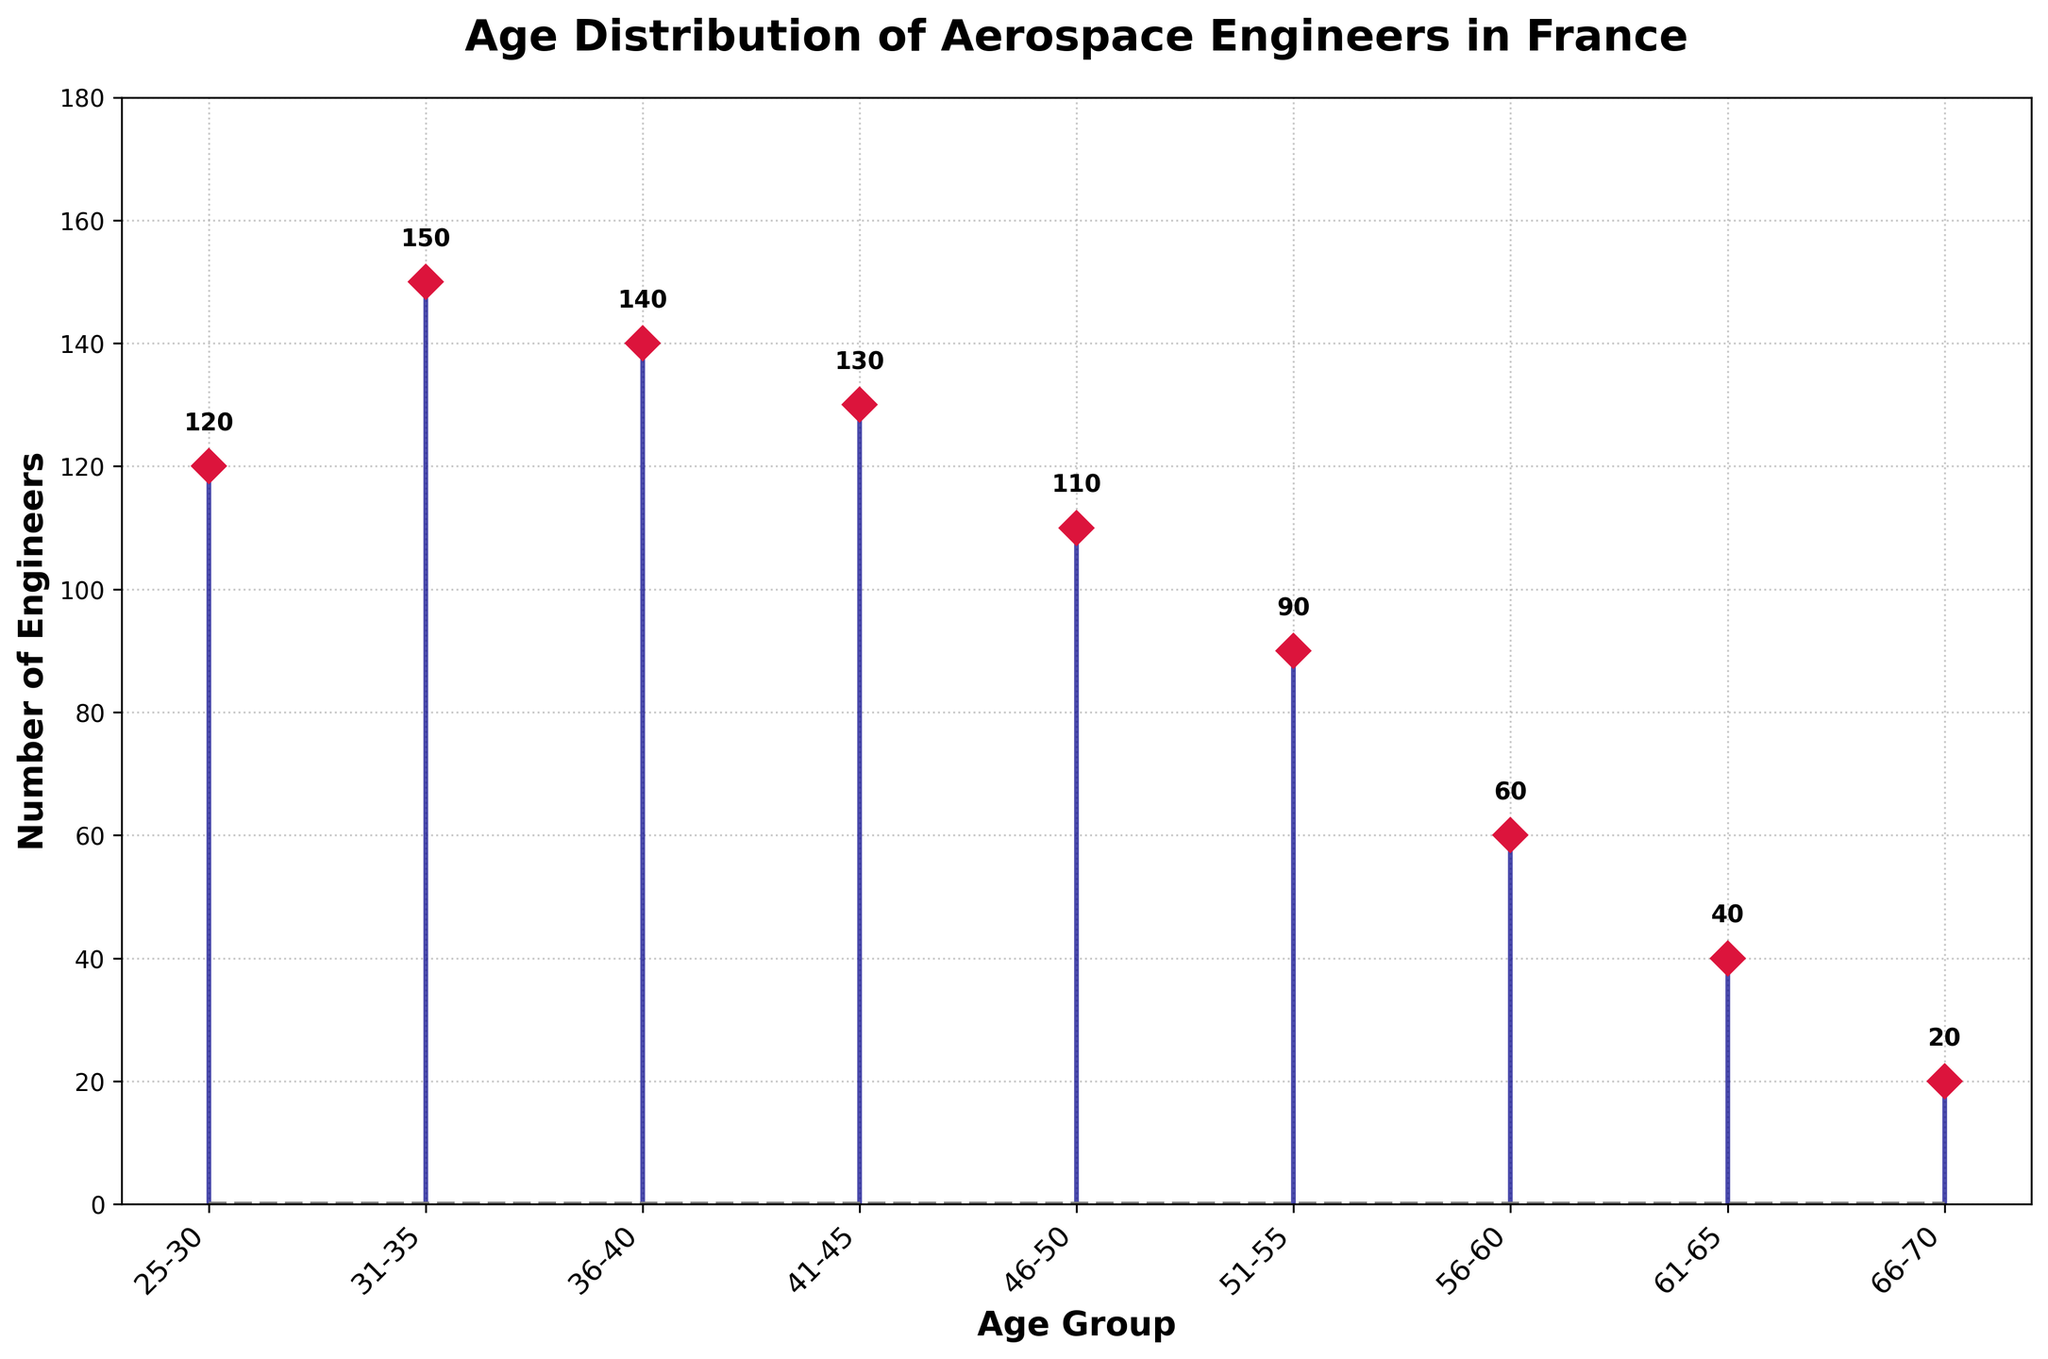What is the age distribution of aerospace engineers in France? The stem plot shows the age groups along the x-axis, ranging from 25-30 to 66-70, with the number of engineers represented by stems on the y-axis. The total number of age groups indicated is 9.
Answer: 9 age groups What is the highest number of engineers in any age group, and which group does it belong to? The tallest stem in the plot represents the highest number, which corresponds to the age group labeled 31-35. The number above this stem is 150.
Answer: 150, 31-35 Which age group has the lowest number of engineers, and how many engineers are in that group? The shortest stem in the plot corresponds to the age group labeled 66-70. The number above this stem is 20.
Answer: 20, 66-70 Compare the number of engineers in the age groups 36-40 and 41-45. Which age group has more engineers? The stems for the age groups 36-40 and 41-45 can be compared by their height and the numbers on top. The number for 36-40 is 140, and for 41-45, it is 130.
Answer: 36-40 What is the total number of aerospace engineers represented in the figure for all age groups? Sum the values of all the stems: 120 + 150 + 140 + 130 + 110 + 90 + 60 + 40 + 20 = 860.
Answer: 860 What is the average number of engineers per age group? Divide the total number of engineers by the number of age groups: 860 / 9 ≈ 95.56.
Answer: 95.56 Which age groups have at least 100 aerospace engineers? Identify the age groups by comparing the heights of the stems to find those with numbers above 100: 25-30 (120), 31-35 (150), 36-40 (140), 41-45 (130), 46-50 (110).
Answer: 25-30, 31-35, 36-40, 41-45, 46-50 What is the difference in the number of engineers between the age groups 51-55 and 56-60? Subtract the number of engineers in 56-60 from 51-55: 90 - 60 = 30.
Answer: 30 How does the number of engineers change as the age groups progress from 25-30 to 66-70? Identify the trend by observing the decreasing height of the stems from left (25-30) to right (66-70): The numbers generally decrease as the age groups increase.
Answer: Decreasing trend 